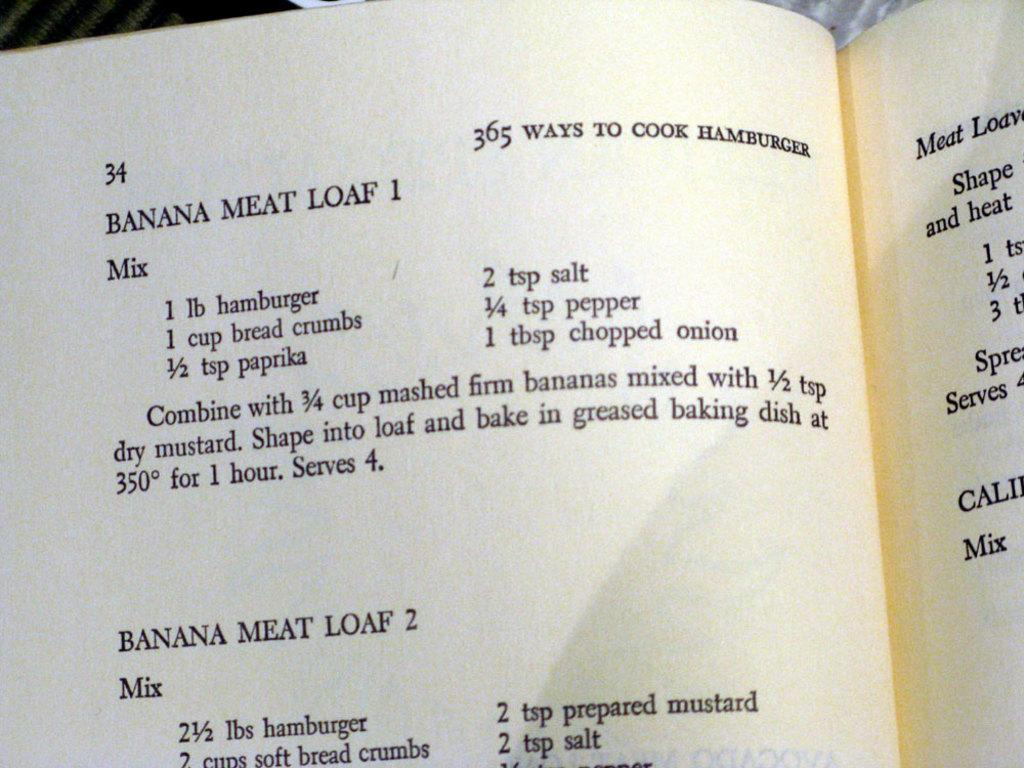Provide a one-sentence caption for the provided image. Book open to a recipe for banana meat loaf. 